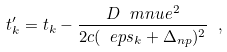<formula> <loc_0><loc_0><loc_500><loc_500>t ^ { \prime } _ { k } = t _ { k } - \frac { D \ m n u e ^ { 2 } } { 2 c ( \ e p s _ { k } + \Delta _ { n p } ) ^ { 2 } } \ ,</formula> 